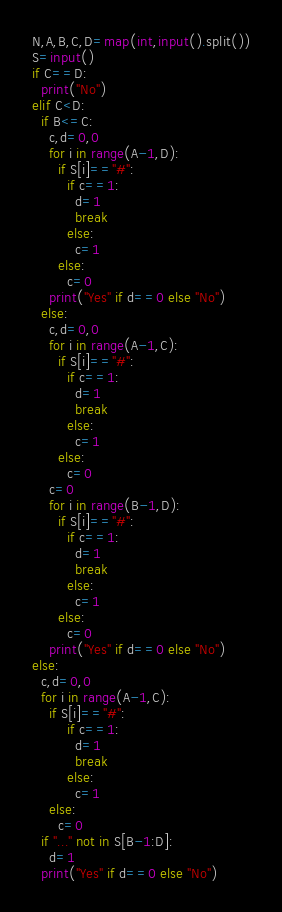<code> <loc_0><loc_0><loc_500><loc_500><_Python_>N,A,B,C,D=map(int,input().split())
S=input()
if C==D:
  print("No")
elif C<D:
  if B<=C:
    c,d=0,0
    for i in range(A-1,D):
      if S[i]=="#":
        if c==1:
          d=1
          break
        else:
          c=1
      else:
        c=0
    print("Yes" if d==0 else "No")
  else:
    c,d=0,0
    for i in range(A-1,C):
      if S[i]=="#":
        if c==1:
          d=1
          break
        else:
          c=1
      else:
        c=0
    c=0
    for i in range(B-1,D):
      if S[i]=="#":
        if c==1:
          d=1
          break
        else:
          c=1
      else:
        c=0
    print("Yes" if d==0 else "No") 
else:
  c,d=0,0
  for i in range(A-1,C):
    if S[i]=="#":
        if c==1:
          d=1
          break
        else:
          c=1
    else:
      c=0
  if "..." not in S[B-1:D]:
    d=1
  print("Yes" if d==0 else "No") </code> 